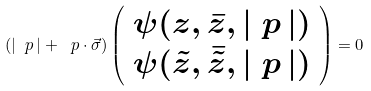Convert formula to latex. <formula><loc_0><loc_0><loc_500><loc_500>( | \ p \, | + \ p \cdot \vec { \sigma } ) \left ( \begin{array} { c } \psi ( z , \bar { z } , | \ p \, | ) \\ \psi ( \tilde { z } , \bar { \tilde { z } } , | \ p \, | ) \end{array} \right ) = 0</formula> 